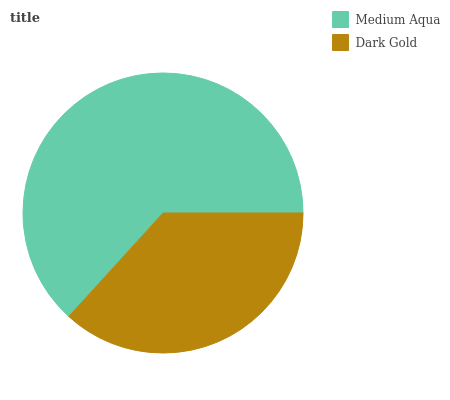Is Dark Gold the minimum?
Answer yes or no. Yes. Is Medium Aqua the maximum?
Answer yes or no. Yes. Is Dark Gold the maximum?
Answer yes or no. No. Is Medium Aqua greater than Dark Gold?
Answer yes or no. Yes. Is Dark Gold less than Medium Aqua?
Answer yes or no. Yes. Is Dark Gold greater than Medium Aqua?
Answer yes or no. No. Is Medium Aqua less than Dark Gold?
Answer yes or no. No. Is Medium Aqua the high median?
Answer yes or no. Yes. Is Dark Gold the low median?
Answer yes or no. Yes. Is Dark Gold the high median?
Answer yes or no. No. Is Medium Aqua the low median?
Answer yes or no. No. 